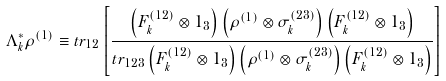Convert formula to latex. <formula><loc_0><loc_0><loc_500><loc_500>\Lambda _ { k } ^ { * } \rho ^ { ( 1 ) } \equiv t r _ { 1 2 } \left [ { \frac { \left ( F _ { k } ^ { ( 1 2 ) } \otimes 1 _ { 3 } \right ) \left ( \rho ^ { ( 1 ) } \otimes \sigma _ { k } ^ { ( 2 3 ) } \right ) \left ( F _ { k } ^ { ( 1 2 ) } \otimes 1 _ { 3 } \right ) } { t r _ { 1 2 3 } \left ( F _ { k } ^ { ( 1 2 ) } \otimes 1 _ { 3 } \right ) \left ( \rho ^ { ( 1 ) } \otimes \sigma _ { k } ^ { ( 2 3 ) } \right ) \left ( F _ { k } ^ { ( 1 2 ) } \otimes 1 _ { 3 } \right ) } } \right ]</formula> 